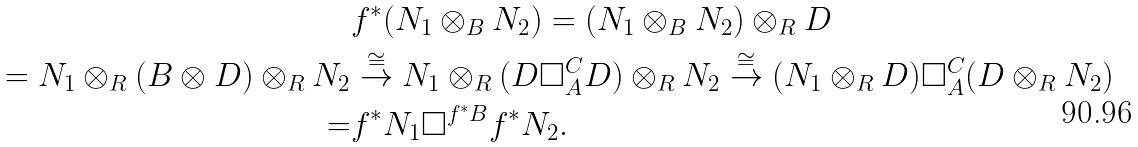<formula> <loc_0><loc_0><loc_500><loc_500>& f ^ { * } ( N _ { 1 } \otimes _ { B } N _ { 2 } ) = ( N _ { 1 } \otimes _ { B } N _ { 2 } ) \otimes _ { R } D \\ = N _ { 1 } \otimes _ { R } ( B \otimes D ) \otimes _ { R } N _ { 2 } & \stackrel { \cong } { \rightarrow } N _ { 1 } \otimes _ { R } ( D \square ^ { C } _ { A } D ) \otimes _ { R } N _ { 2 } \stackrel { \cong } { \rightarrow } ( N _ { 1 } \otimes _ { R } D ) \square _ { A } ^ { C } ( D \otimes _ { R } N _ { 2 } ) \\ = & f ^ { * } N _ { 1 } \square ^ { f ^ { * } B } f ^ { * } N _ { 2 } .</formula> 